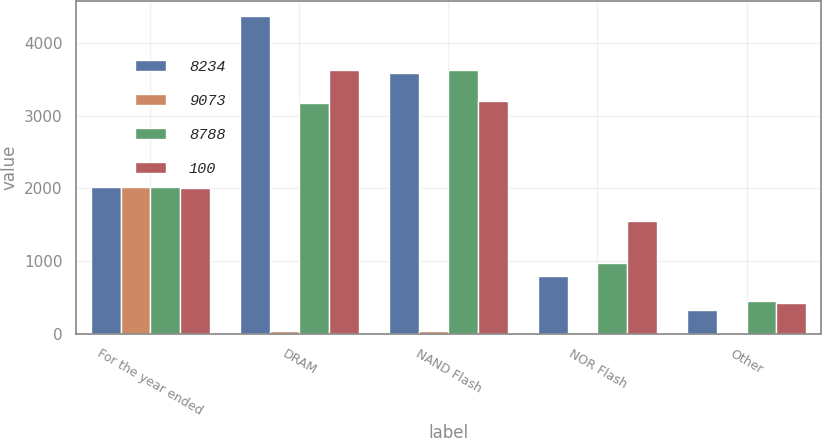<chart> <loc_0><loc_0><loc_500><loc_500><stacked_bar_chart><ecel><fcel>For the year ended<fcel>DRAM<fcel>NAND Flash<fcel>NOR Flash<fcel>Other<nl><fcel>8234<fcel>2013<fcel>4361<fcel>3589<fcel>792<fcel>331<nl><fcel>9073<fcel>2013<fcel>48<fcel>40<fcel>9<fcel>3<nl><fcel>8788<fcel>2012<fcel>3178<fcel>3627<fcel>977<fcel>452<nl><fcel>100<fcel>2011<fcel>3620<fcel>3193<fcel>1547<fcel>428<nl></chart> 